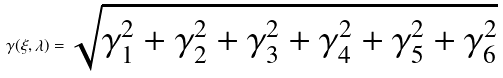Convert formula to latex. <formula><loc_0><loc_0><loc_500><loc_500>\gamma ( \xi , \lambda ) = \sqrt { \gamma _ { 1 } ^ { 2 } + \gamma _ { 2 } ^ { 2 } + \gamma _ { 3 } ^ { 2 } + \gamma _ { 4 } ^ { 2 } + \gamma _ { 5 } ^ { 2 } + \gamma _ { 6 } ^ { 2 } }</formula> 